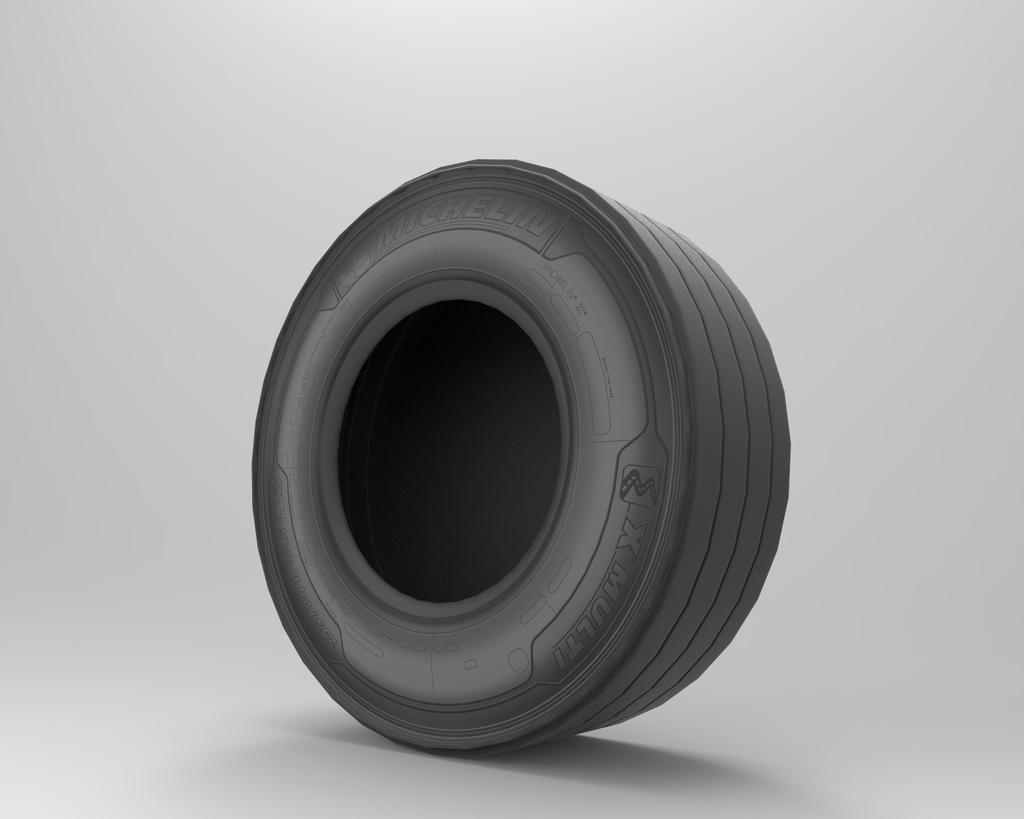Can you describe this image briefly? In this image the background is white in color. In the middle of the image there is a tire which is black in color. 